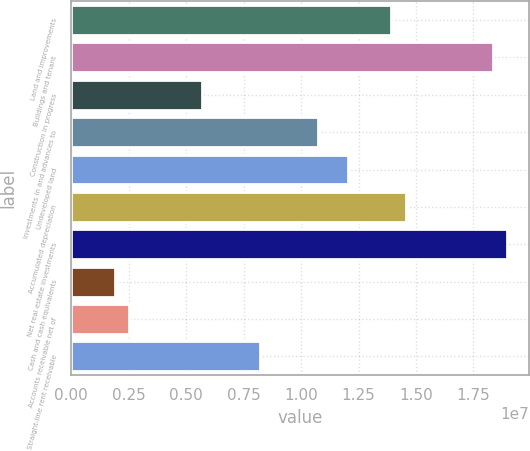<chart> <loc_0><loc_0><loc_500><loc_500><bar_chart><fcel>Land and improvements<fcel>Buildings and tenant<fcel>Construction in progress<fcel>Investments in and advances to<fcel>Undeveloped land<fcel>Accumulated depreciation<fcel>Net real estate investments<fcel>Cash and cash equivalents<fcel>Accounts receivable net of<fcel>Straight-line rent receivable<nl><fcel>1.39162e+07<fcel>1.83436e+07<fcel>5.69384e+06<fcel>1.07538e+07<fcel>1.20187e+07<fcel>1.45487e+07<fcel>1.89761e+07<fcel>1.8989e+06<fcel>2.53139e+06<fcel>8.2238e+06<nl></chart> 